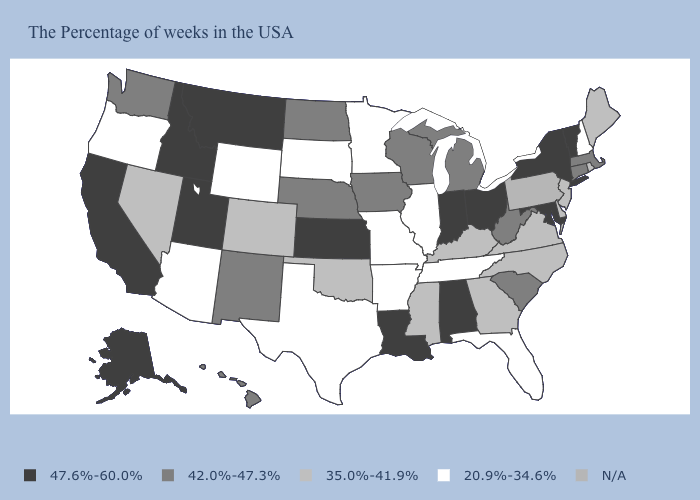How many symbols are there in the legend?
Answer briefly. 5. Name the states that have a value in the range N/A?
Be succinct. Pennsylvania. What is the value of Massachusetts?
Be succinct. 42.0%-47.3%. Name the states that have a value in the range 20.9%-34.6%?
Quick response, please. New Hampshire, Florida, Tennessee, Illinois, Missouri, Arkansas, Minnesota, Texas, South Dakota, Wyoming, Arizona, Oregon. Name the states that have a value in the range 20.9%-34.6%?
Concise answer only. New Hampshire, Florida, Tennessee, Illinois, Missouri, Arkansas, Minnesota, Texas, South Dakota, Wyoming, Arizona, Oregon. Name the states that have a value in the range 42.0%-47.3%?
Concise answer only. Massachusetts, Connecticut, South Carolina, West Virginia, Michigan, Wisconsin, Iowa, Nebraska, North Dakota, New Mexico, Washington, Hawaii. Does Vermont have the highest value in the USA?
Short answer required. Yes. What is the value of Missouri?
Write a very short answer. 20.9%-34.6%. Name the states that have a value in the range 47.6%-60.0%?
Short answer required. Vermont, New York, Maryland, Ohio, Indiana, Alabama, Louisiana, Kansas, Utah, Montana, Idaho, California, Alaska. How many symbols are there in the legend?
Short answer required. 5. What is the value of Maine?
Short answer required. 35.0%-41.9%. Among the states that border Utah , does New Mexico have the highest value?
Answer briefly. No. Does the map have missing data?
Concise answer only. Yes. Among the states that border Nevada , does Utah have the lowest value?
Write a very short answer. No. 